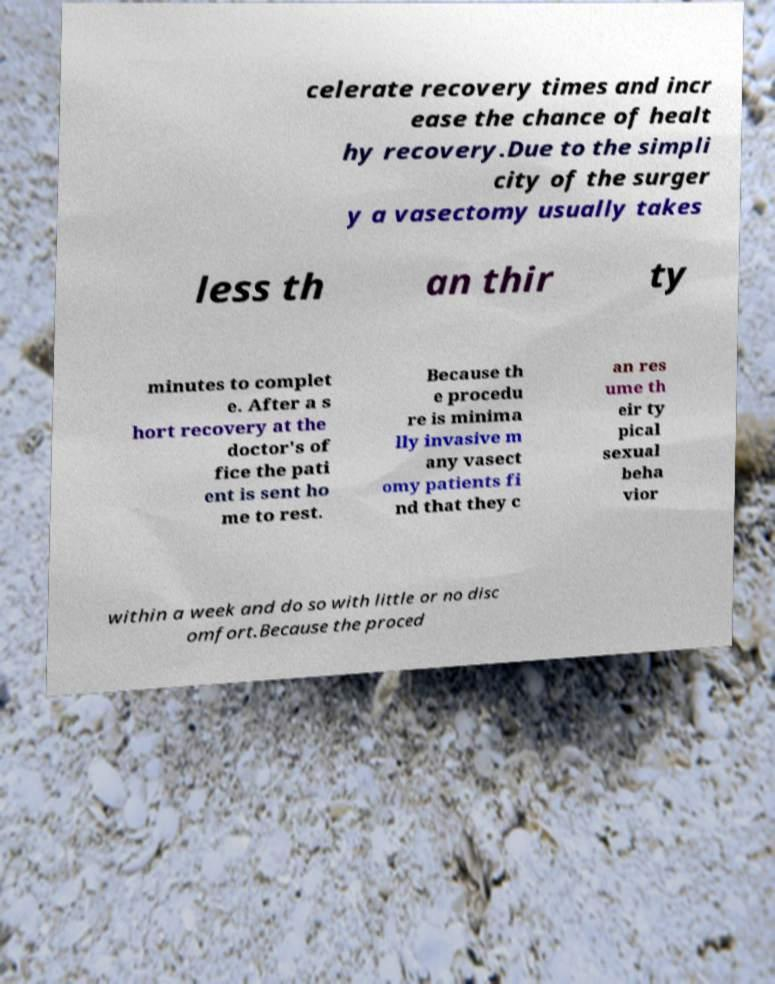Could you extract and type out the text from this image? celerate recovery times and incr ease the chance of healt hy recovery.Due to the simpli city of the surger y a vasectomy usually takes less th an thir ty minutes to complet e. After a s hort recovery at the doctor's of fice the pati ent is sent ho me to rest. Because th e procedu re is minima lly invasive m any vasect omy patients fi nd that they c an res ume th eir ty pical sexual beha vior within a week and do so with little or no disc omfort.Because the proced 